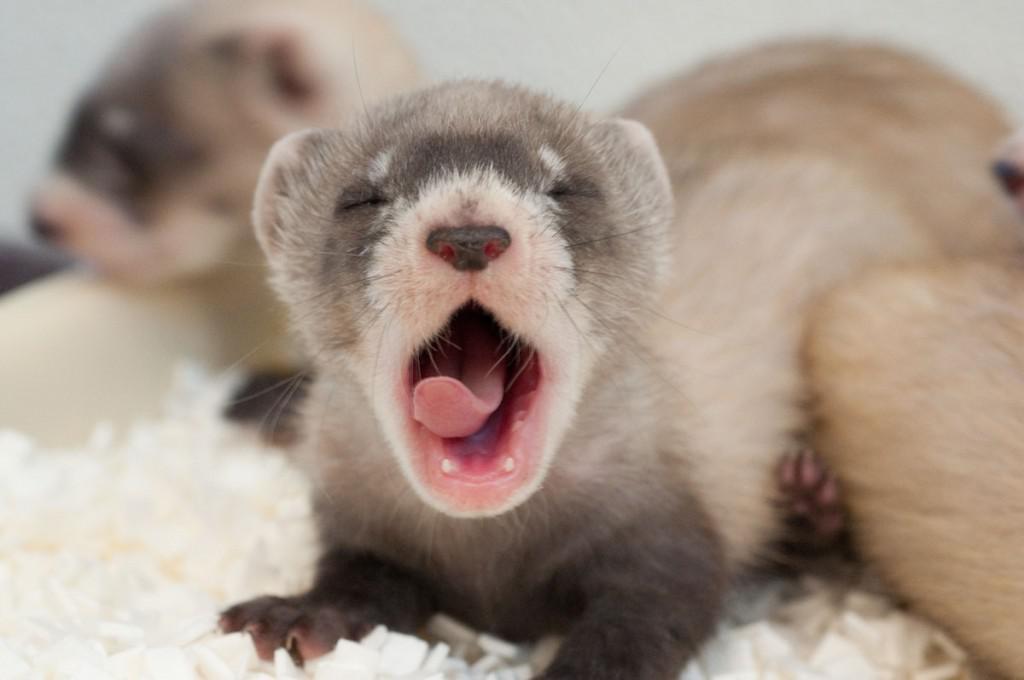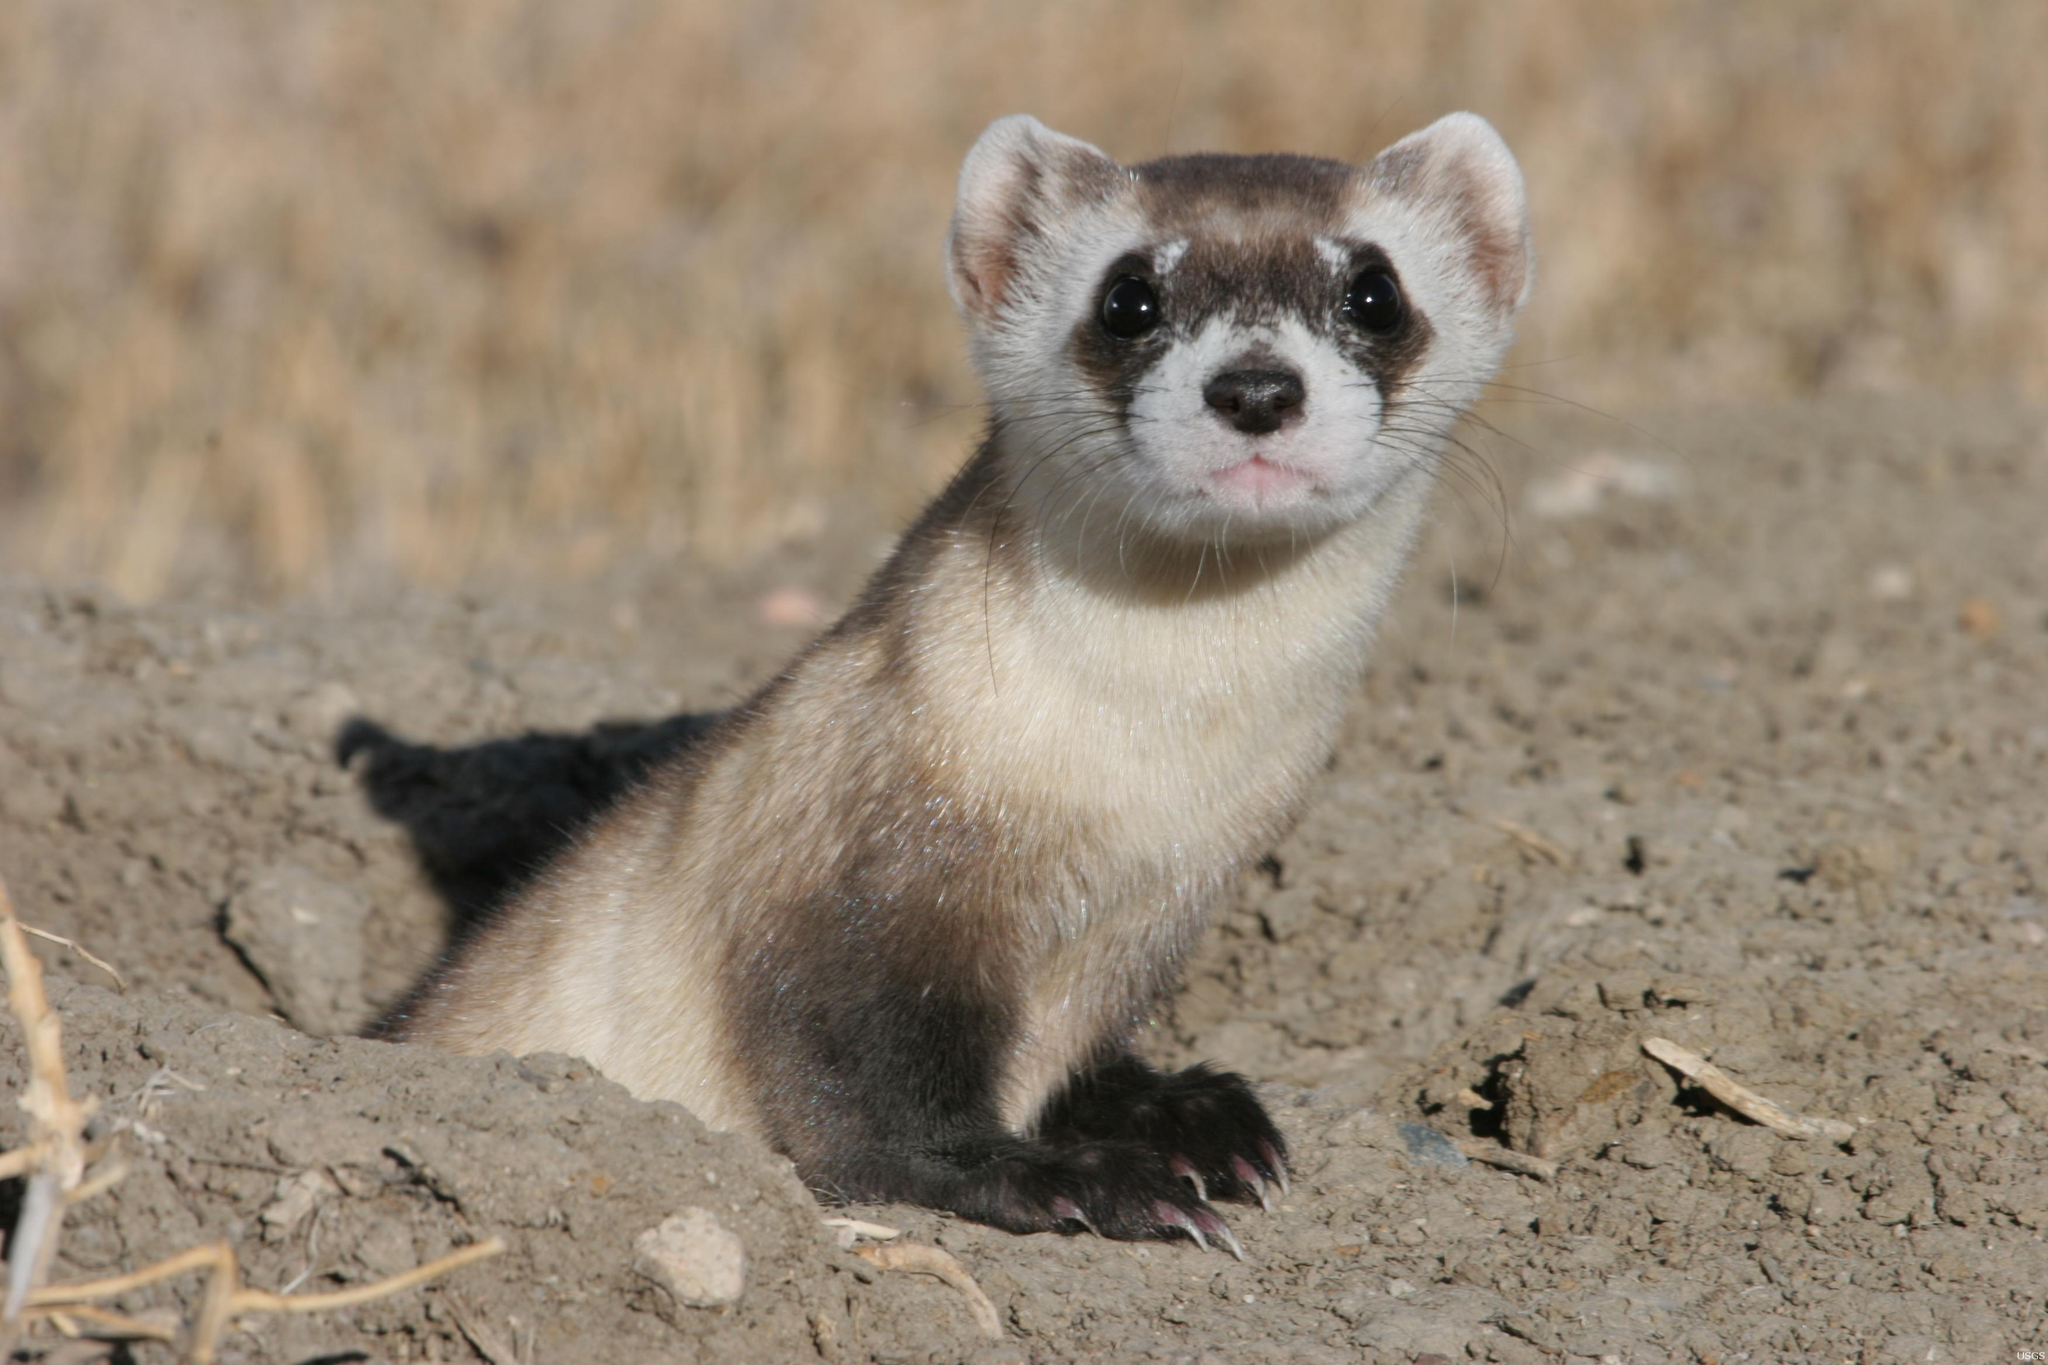The first image is the image on the left, the second image is the image on the right. Analyze the images presented: Is the assertion "In one of the photos, the animal has its mouth wide open." valid? Answer yes or no. Yes. The first image is the image on the left, the second image is the image on the right. For the images shown, is this caption "in one image there is a lone black footed ferret looking out from a hole in the ground." true? Answer yes or no. Yes. 